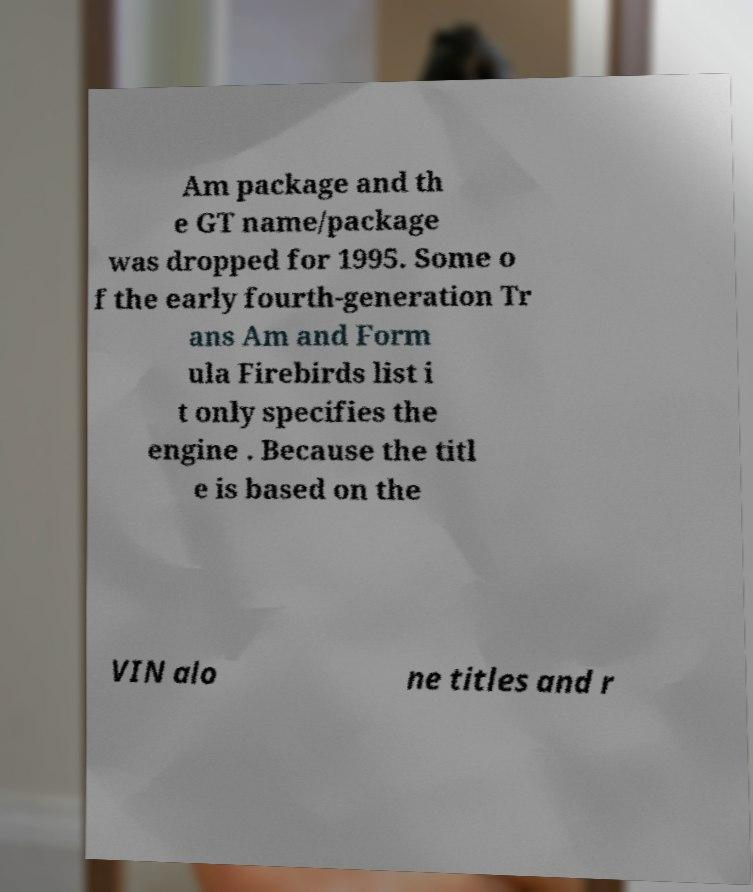Could you assist in decoding the text presented in this image and type it out clearly? Am package and th e GT name/package was dropped for 1995. Some o f the early fourth-generation Tr ans Am and Form ula Firebirds list i t only specifies the engine . Because the titl e is based on the VIN alo ne titles and r 